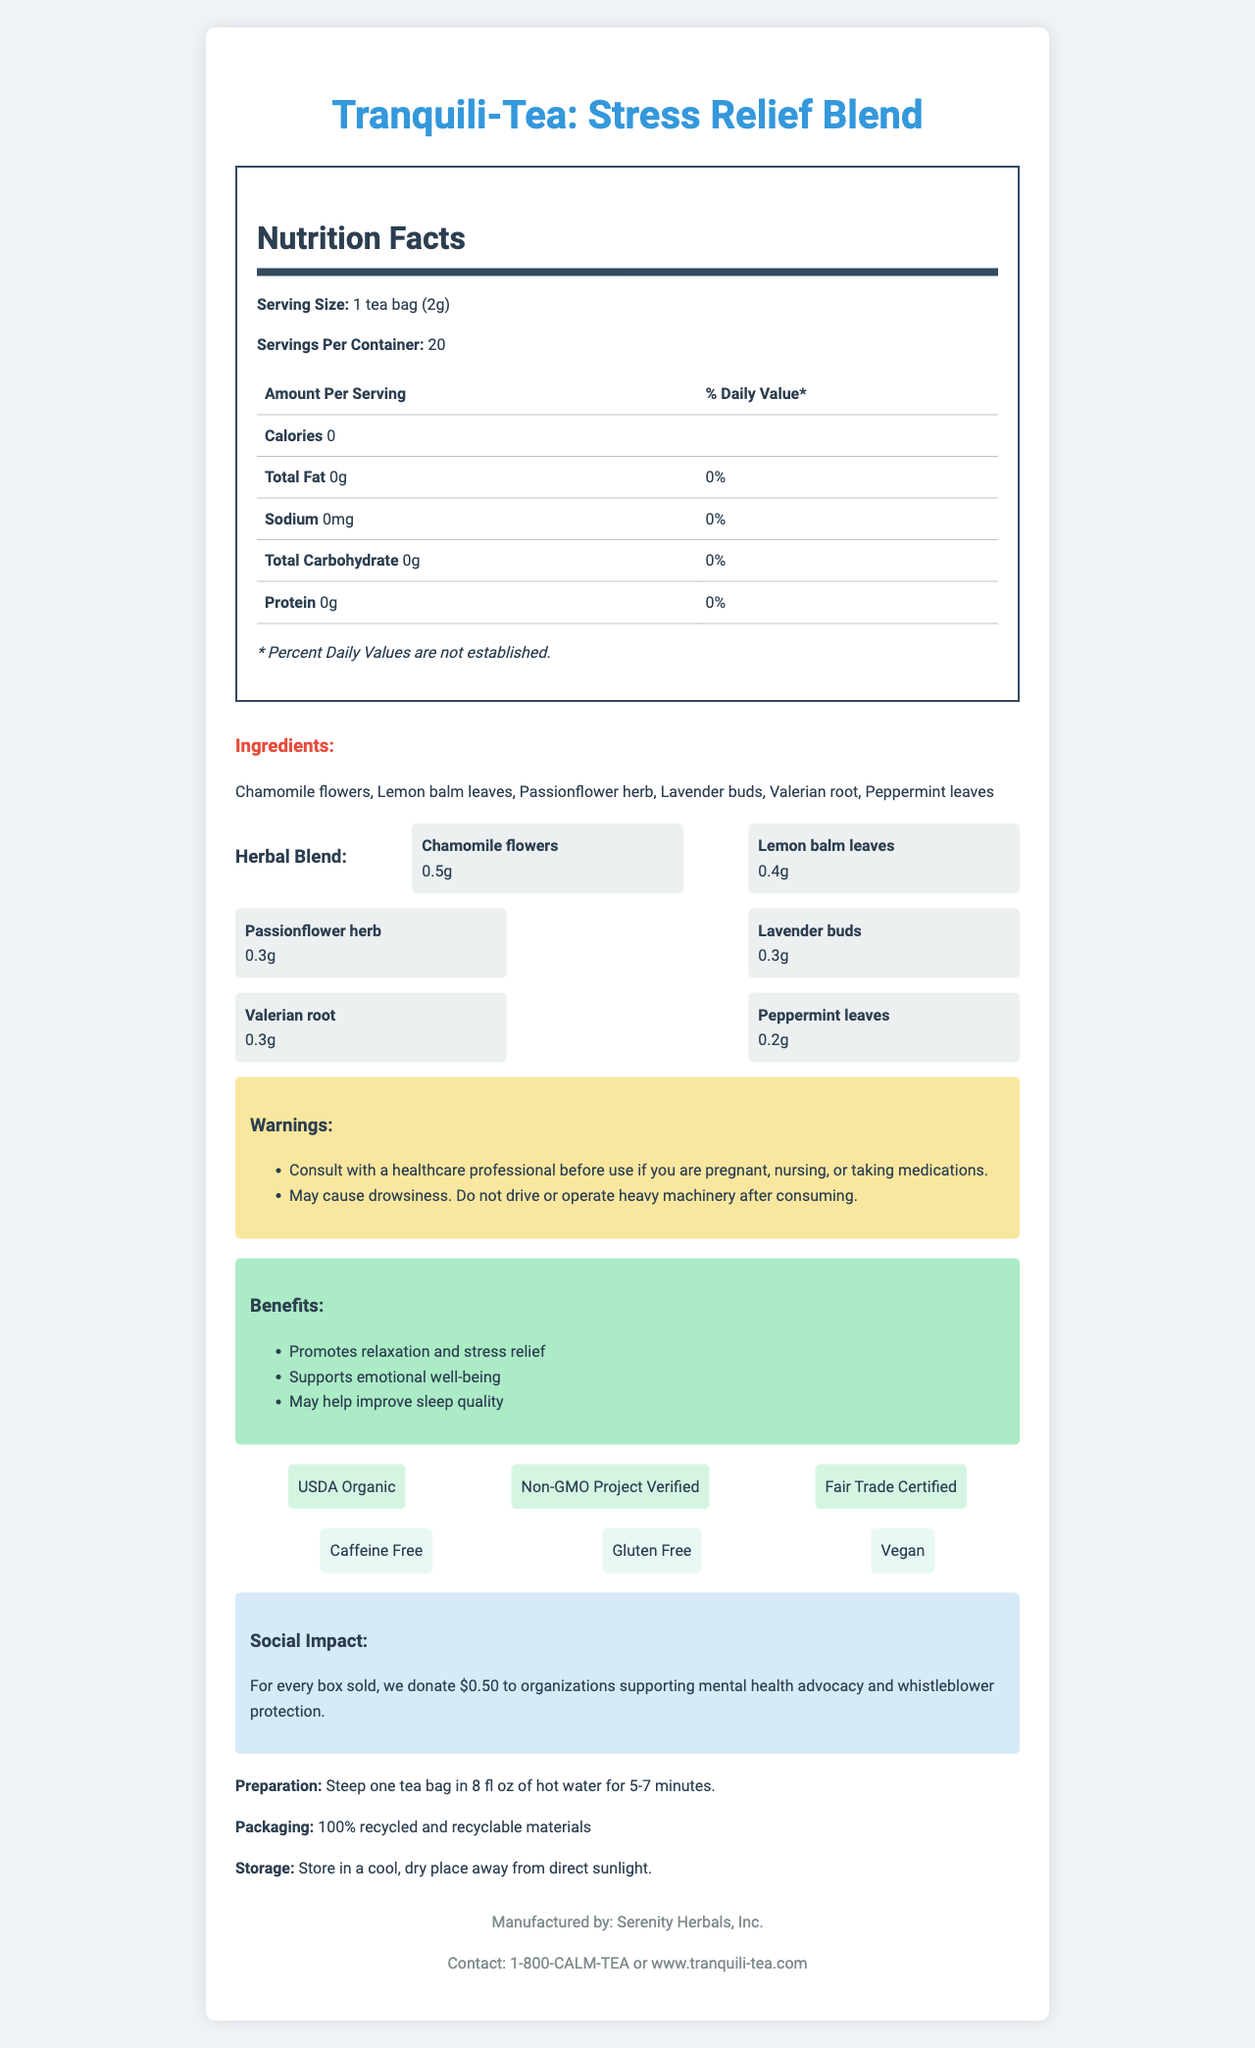what is the serving size? The serving size is clearly mentioned at the beginning of the document under the Nutrition Facts section.
Answer: 1 tea bag (2g) how many servings are there per container? The document states "Servings Per Container: 20" under the Nutrition Facts section.
Answer: 20 how many calories does one serving contain? The Nutrition Facts section lists "Calories 0" under the Amount Per Serving subheading.
Answer: 0 what are the ingredients? The ingredients are listed after the Nutrition Facts section under the Ingredients heading.
Answer: Chamomile flowers, Lemon balm leaves, Passionflower herb, Lavender buds, Valerian root, Peppermint leaves what is the main function of this tea blend? The Benefits section lists the primary function as "Promotes relaxation and stress relief."
Answer: Promotes relaxation and stress relief what should you do before using this product if you are pregnant or nursing? The Warnings section advises to "Consult with a healthcare professional before use if you are pregnant, nursing, or taking medications."
Answer: Consult with a healthcare professional how much Chamomile flowers are in the herbal blend? The Herbal Blend section lists "Chamomile flowers: 0.5g."
Answer: 0.5g where should you store this product? The Storage section states "Store in a cool, dry place away from direct sunlight."
Answer: In a cool, dry place away from direct sunlight what is the social impact of purchasing this tea? The Social Impact section describes the donation made for each box sold.
Answer: For every box sold, we donate $0.50 to organizations supporting mental health advocacy and whistleblower protection how should this tea be prepared? A. Steep one tea bag in 8 fl oz of hot water for 3-5 minutes B. Steep one tea bag in 8 fl oz of hot water for 5-7 minutes C. Steep one tea bag in 10 fl oz of hot water for 5-7 minutes The preparation instructions state "Steep one tea bag in 8 fl oz of hot water for 5-7 minutes."
Answer: B what certifications does this tea have? A. USDA Organic B. Non-GMO Project Verified C. Fair Trade Certified D. All of the above The Certifications section includes "USDA Organic," "Non-GMO Project Verified," and "Fair Trade Certified."
Answer: D is this tea blend caffeine-free? The Additional Info section states it is caffeine-free.
Answer: Yes is this tea likely to cause drowsiness? One of the warnings mentions "May cause drowsiness."
Answer: Yes summarize the entire document. The document lists all the pertinent details regarding the product, including its nutritional information, ingredients, benefits, usage warnings, and social and environmental impact, providing a comprehensive overview of the Tranquili-Tea: Stress Relief Blend.
Answer: The document provides detailed information about Tranquili-Tea: Stress Relief Blend, including its nutrition facts, ingredients, herbal blend composition, benefits, warnings, preparation instructions, and social impact. The tea is designed to promote relaxation and stress relief and comes with certifications like USDA Organic and Non-GMO Project Verified. It is caffeine-free, gluten-free, and vegan. The tea's packaging is made from recycled materials, and each purchase supports mental health advocacy and whistleblower protection. how much Lavender buds are in each serving? The Herbal Blend section specifically lists "Lavender buds: 0.3g."
Answer: 0.3g can the calorie intake from this tea contribute to a daily caloric intake? Each serving contains 0 calories, so it does not contribute to daily caloric intake.
Answer: No how many grams of Peppermint leaves are there in one herbal blend? The Herbal Blend section lists "Peppermint leaves: 0.2g."
Answer: 0.2g who manufactures this tea? The manufacturer information is found at the end of the document and states "Manufactured by: Serenity Herbals, Inc."
Answer: Serenity Herbals, Inc. does this tea contain any fat? The Nutrition Facts section under Total Fat lists "0g," indicating no fat content.
Answer: No why shouldn't you operate heavy machinery after consuming this tea? One of the warnings in the document states, "May cause drowsiness. Do not drive or operate heavy machinery after consuming."
Answer: May cause drowsiness can we determine if this tea blend is made using artificial flavors? The document does not provide information on whether artificial flavors are used.
Answer: Not enough information what is the cost of one box of this tea? The document does not provide any pricing information.
Answer: Cannot be determined 